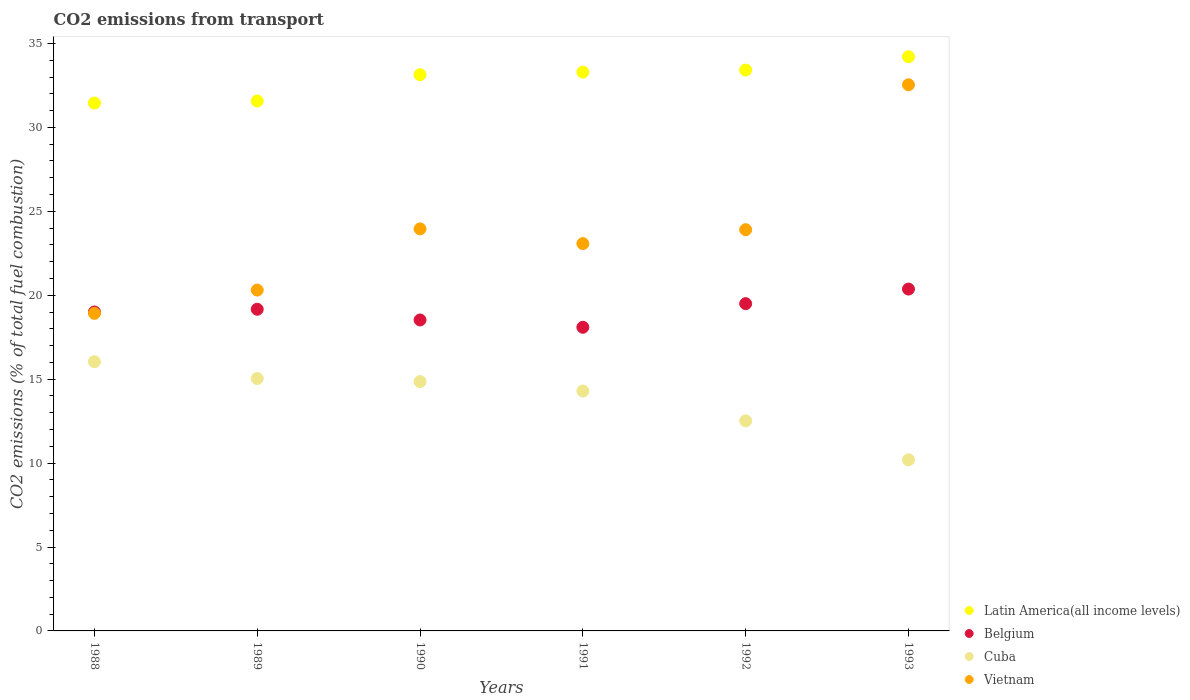How many different coloured dotlines are there?
Make the answer very short. 4. Is the number of dotlines equal to the number of legend labels?
Offer a terse response. Yes. What is the total CO2 emitted in Vietnam in 1990?
Your response must be concise. 23.95. Across all years, what is the maximum total CO2 emitted in Cuba?
Your response must be concise. 16.04. Across all years, what is the minimum total CO2 emitted in Cuba?
Your answer should be compact. 10.19. What is the total total CO2 emitted in Belgium in the graph?
Ensure brevity in your answer.  114.66. What is the difference between the total CO2 emitted in Belgium in 1989 and that in 1993?
Make the answer very short. -1.2. What is the difference between the total CO2 emitted in Vietnam in 1992 and the total CO2 emitted in Cuba in 1989?
Offer a terse response. 8.87. What is the average total CO2 emitted in Cuba per year?
Your answer should be very brief. 13.82. In the year 1993, what is the difference between the total CO2 emitted in Belgium and total CO2 emitted in Vietnam?
Your answer should be compact. -12.17. In how many years, is the total CO2 emitted in Cuba greater than 28?
Offer a terse response. 0. What is the ratio of the total CO2 emitted in Cuba in 1989 to that in 1993?
Your response must be concise. 1.48. What is the difference between the highest and the second highest total CO2 emitted in Latin America(all income levels)?
Your answer should be very brief. 0.79. What is the difference between the highest and the lowest total CO2 emitted in Cuba?
Provide a short and direct response. 5.85. In how many years, is the total CO2 emitted in Vietnam greater than the average total CO2 emitted in Vietnam taken over all years?
Offer a very short reply. 3. Is it the case that in every year, the sum of the total CO2 emitted in Vietnam and total CO2 emitted in Cuba  is greater than the sum of total CO2 emitted in Belgium and total CO2 emitted in Latin America(all income levels)?
Offer a very short reply. No. Is the total CO2 emitted in Vietnam strictly greater than the total CO2 emitted in Cuba over the years?
Offer a very short reply. Yes. Is the total CO2 emitted in Vietnam strictly less than the total CO2 emitted in Belgium over the years?
Ensure brevity in your answer.  No. How many dotlines are there?
Your response must be concise. 4. How many years are there in the graph?
Your response must be concise. 6. Are the values on the major ticks of Y-axis written in scientific E-notation?
Offer a terse response. No. Does the graph contain any zero values?
Offer a very short reply. No. Where does the legend appear in the graph?
Keep it short and to the point. Bottom right. What is the title of the graph?
Your answer should be very brief. CO2 emissions from transport. Does "Russian Federation" appear as one of the legend labels in the graph?
Offer a very short reply. No. What is the label or title of the X-axis?
Offer a very short reply. Years. What is the label or title of the Y-axis?
Make the answer very short. CO2 emissions (% of total fuel combustion). What is the CO2 emissions (% of total fuel combustion) in Latin America(all income levels) in 1988?
Your answer should be very brief. 31.45. What is the CO2 emissions (% of total fuel combustion) in Belgium in 1988?
Provide a short and direct response. 19. What is the CO2 emissions (% of total fuel combustion) of Cuba in 1988?
Offer a terse response. 16.04. What is the CO2 emissions (% of total fuel combustion) in Vietnam in 1988?
Ensure brevity in your answer.  18.92. What is the CO2 emissions (% of total fuel combustion) of Latin America(all income levels) in 1989?
Your answer should be compact. 31.57. What is the CO2 emissions (% of total fuel combustion) of Belgium in 1989?
Ensure brevity in your answer.  19.17. What is the CO2 emissions (% of total fuel combustion) of Cuba in 1989?
Your answer should be compact. 15.04. What is the CO2 emissions (% of total fuel combustion) in Vietnam in 1989?
Offer a terse response. 20.31. What is the CO2 emissions (% of total fuel combustion) in Latin America(all income levels) in 1990?
Make the answer very short. 33.14. What is the CO2 emissions (% of total fuel combustion) of Belgium in 1990?
Ensure brevity in your answer.  18.53. What is the CO2 emissions (% of total fuel combustion) in Cuba in 1990?
Offer a very short reply. 14.86. What is the CO2 emissions (% of total fuel combustion) in Vietnam in 1990?
Offer a terse response. 23.95. What is the CO2 emissions (% of total fuel combustion) in Latin America(all income levels) in 1991?
Make the answer very short. 33.29. What is the CO2 emissions (% of total fuel combustion) of Belgium in 1991?
Offer a terse response. 18.09. What is the CO2 emissions (% of total fuel combustion) of Cuba in 1991?
Offer a very short reply. 14.3. What is the CO2 emissions (% of total fuel combustion) of Vietnam in 1991?
Give a very brief answer. 23.08. What is the CO2 emissions (% of total fuel combustion) in Latin America(all income levels) in 1992?
Offer a terse response. 33.42. What is the CO2 emissions (% of total fuel combustion) in Belgium in 1992?
Offer a very short reply. 19.5. What is the CO2 emissions (% of total fuel combustion) of Cuba in 1992?
Provide a succinct answer. 12.52. What is the CO2 emissions (% of total fuel combustion) in Vietnam in 1992?
Your response must be concise. 23.91. What is the CO2 emissions (% of total fuel combustion) of Latin America(all income levels) in 1993?
Offer a very short reply. 34.21. What is the CO2 emissions (% of total fuel combustion) of Belgium in 1993?
Give a very brief answer. 20.37. What is the CO2 emissions (% of total fuel combustion) in Cuba in 1993?
Ensure brevity in your answer.  10.19. What is the CO2 emissions (% of total fuel combustion) of Vietnam in 1993?
Ensure brevity in your answer.  32.54. Across all years, what is the maximum CO2 emissions (% of total fuel combustion) of Latin America(all income levels)?
Give a very brief answer. 34.21. Across all years, what is the maximum CO2 emissions (% of total fuel combustion) in Belgium?
Your response must be concise. 20.37. Across all years, what is the maximum CO2 emissions (% of total fuel combustion) in Cuba?
Give a very brief answer. 16.04. Across all years, what is the maximum CO2 emissions (% of total fuel combustion) in Vietnam?
Give a very brief answer. 32.54. Across all years, what is the minimum CO2 emissions (% of total fuel combustion) in Latin America(all income levels)?
Keep it short and to the point. 31.45. Across all years, what is the minimum CO2 emissions (% of total fuel combustion) of Belgium?
Ensure brevity in your answer.  18.09. Across all years, what is the minimum CO2 emissions (% of total fuel combustion) of Cuba?
Provide a succinct answer. 10.19. Across all years, what is the minimum CO2 emissions (% of total fuel combustion) of Vietnam?
Your answer should be compact. 18.92. What is the total CO2 emissions (% of total fuel combustion) of Latin America(all income levels) in the graph?
Keep it short and to the point. 197.09. What is the total CO2 emissions (% of total fuel combustion) of Belgium in the graph?
Provide a succinct answer. 114.66. What is the total CO2 emissions (% of total fuel combustion) of Cuba in the graph?
Provide a short and direct response. 82.94. What is the total CO2 emissions (% of total fuel combustion) in Vietnam in the graph?
Ensure brevity in your answer.  142.71. What is the difference between the CO2 emissions (% of total fuel combustion) in Latin America(all income levels) in 1988 and that in 1989?
Your answer should be very brief. -0.12. What is the difference between the CO2 emissions (% of total fuel combustion) in Belgium in 1988 and that in 1989?
Keep it short and to the point. -0.16. What is the difference between the CO2 emissions (% of total fuel combustion) in Vietnam in 1988 and that in 1989?
Offer a very short reply. -1.39. What is the difference between the CO2 emissions (% of total fuel combustion) in Latin America(all income levels) in 1988 and that in 1990?
Your response must be concise. -1.69. What is the difference between the CO2 emissions (% of total fuel combustion) of Belgium in 1988 and that in 1990?
Ensure brevity in your answer.  0.48. What is the difference between the CO2 emissions (% of total fuel combustion) of Cuba in 1988 and that in 1990?
Give a very brief answer. 1.18. What is the difference between the CO2 emissions (% of total fuel combustion) of Vietnam in 1988 and that in 1990?
Provide a succinct answer. -5.03. What is the difference between the CO2 emissions (% of total fuel combustion) in Latin America(all income levels) in 1988 and that in 1991?
Provide a succinct answer. -1.84. What is the difference between the CO2 emissions (% of total fuel combustion) in Belgium in 1988 and that in 1991?
Make the answer very short. 0.91. What is the difference between the CO2 emissions (% of total fuel combustion) of Cuba in 1988 and that in 1991?
Your answer should be compact. 1.74. What is the difference between the CO2 emissions (% of total fuel combustion) of Vietnam in 1988 and that in 1991?
Your answer should be very brief. -4.16. What is the difference between the CO2 emissions (% of total fuel combustion) in Latin America(all income levels) in 1988 and that in 1992?
Offer a terse response. -1.97. What is the difference between the CO2 emissions (% of total fuel combustion) of Belgium in 1988 and that in 1992?
Give a very brief answer. -0.5. What is the difference between the CO2 emissions (% of total fuel combustion) in Cuba in 1988 and that in 1992?
Give a very brief answer. 3.52. What is the difference between the CO2 emissions (% of total fuel combustion) of Vietnam in 1988 and that in 1992?
Your answer should be very brief. -4.98. What is the difference between the CO2 emissions (% of total fuel combustion) in Latin America(all income levels) in 1988 and that in 1993?
Your response must be concise. -2.76. What is the difference between the CO2 emissions (% of total fuel combustion) of Belgium in 1988 and that in 1993?
Ensure brevity in your answer.  -1.36. What is the difference between the CO2 emissions (% of total fuel combustion) of Cuba in 1988 and that in 1993?
Your response must be concise. 5.85. What is the difference between the CO2 emissions (% of total fuel combustion) in Vietnam in 1988 and that in 1993?
Ensure brevity in your answer.  -13.62. What is the difference between the CO2 emissions (% of total fuel combustion) in Latin America(all income levels) in 1989 and that in 1990?
Keep it short and to the point. -1.57. What is the difference between the CO2 emissions (% of total fuel combustion) of Belgium in 1989 and that in 1990?
Make the answer very short. 0.64. What is the difference between the CO2 emissions (% of total fuel combustion) of Cuba in 1989 and that in 1990?
Keep it short and to the point. 0.18. What is the difference between the CO2 emissions (% of total fuel combustion) of Vietnam in 1989 and that in 1990?
Your answer should be very brief. -3.65. What is the difference between the CO2 emissions (% of total fuel combustion) of Latin America(all income levels) in 1989 and that in 1991?
Offer a terse response. -1.72. What is the difference between the CO2 emissions (% of total fuel combustion) in Belgium in 1989 and that in 1991?
Ensure brevity in your answer.  1.07. What is the difference between the CO2 emissions (% of total fuel combustion) of Cuba in 1989 and that in 1991?
Keep it short and to the point. 0.74. What is the difference between the CO2 emissions (% of total fuel combustion) in Vietnam in 1989 and that in 1991?
Your answer should be compact. -2.77. What is the difference between the CO2 emissions (% of total fuel combustion) of Latin America(all income levels) in 1989 and that in 1992?
Offer a terse response. -1.85. What is the difference between the CO2 emissions (% of total fuel combustion) of Belgium in 1989 and that in 1992?
Give a very brief answer. -0.33. What is the difference between the CO2 emissions (% of total fuel combustion) of Cuba in 1989 and that in 1992?
Provide a succinct answer. 2.52. What is the difference between the CO2 emissions (% of total fuel combustion) of Vietnam in 1989 and that in 1992?
Keep it short and to the point. -3.6. What is the difference between the CO2 emissions (% of total fuel combustion) in Latin America(all income levels) in 1989 and that in 1993?
Your response must be concise. -2.64. What is the difference between the CO2 emissions (% of total fuel combustion) in Belgium in 1989 and that in 1993?
Your answer should be very brief. -1.2. What is the difference between the CO2 emissions (% of total fuel combustion) of Cuba in 1989 and that in 1993?
Give a very brief answer. 4.85. What is the difference between the CO2 emissions (% of total fuel combustion) of Vietnam in 1989 and that in 1993?
Provide a short and direct response. -12.23. What is the difference between the CO2 emissions (% of total fuel combustion) of Latin America(all income levels) in 1990 and that in 1991?
Offer a very short reply. -0.15. What is the difference between the CO2 emissions (% of total fuel combustion) of Belgium in 1990 and that in 1991?
Offer a very short reply. 0.44. What is the difference between the CO2 emissions (% of total fuel combustion) of Cuba in 1990 and that in 1991?
Ensure brevity in your answer.  0.56. What is the difference between the CO2 emissions (% of total fuel combustion) in Vietnam in 1990 and that in 1991?
Provide a succinct answer. 0.88. What is the difference between the CO2 emissions (% of total fuel combustion) in Latin America(all income levels) in 1990 and that in 1992?
Your answer should be very brief. -0.27. What is the difference between the CO2 emissions (% of total fuel combustion) in Belgium in 1990 and that in 1992?
Make the answer very short. -0.97. What is the difference between the CO2 emissions (% of total fuel combustion) in Cuba in 1990 and that in 1992?
Give a very brief answer. 2.34. What is the difference between the CO2 emissions (% of total fuel combustion) in Vietnam in 1990 and that in 1992?
Ensure brevity in your answer.  0.05. What is the difference between the CO2 emissions (% of total fuel combustion) of Latin America(all income levels) in 1990 and that in 1993?
Make the answer very short. -1.07. What is the difference between the CO2 emissions (% of total fuel combustion) in Belgium in 1990 and that in 1993?
Give a very brief answer. -1.84. What is the difference between the CO2 emissions (% of total fuel combustion) of Cuba in 1990 and that in 1993?
Your answer should be very brief. 4.66. What is the difference between the CO2 emissions (% of total fuel combustion) of Vietnam in 1990 and that in 1993?
Ensure brevity in your answer.  -8.59. What is the difference between the CO2 emissions (% of total fuel combustion) of Latin America(all income levels) in 1991 and that in 1992?
Give a very brief answer. -0.13. What is the difference between the CO2 emissions (% of total fuel combustion) in Belgium in 1991 and that in 1992?
Provide a succinct answer. -1.41. What is the difference between the CO2 emissions (% of total fuel combustion) of Cuba in 1991 and that in 1992?
Offer a very short reply. 1.78. What is the difference between the CO2 emissions (% of total fuel combustion) of Vietnam in 1991 and that in 1992?
Keep it short and to the point. -0.83. What is the difference between the CO2 emissions (% of total fuel combustion) of Latin America(all income levels) in 1991 and that in 1993?
Your answer should be very brief. -0.92. What is the difference between the CO2 emissions (% of total fuel combustion) of Belgium in 1991 and that in 1993?
Ensure brevity in your answer.  -2.28. What is the difference between the CO2 emissions (% of total fuel combustion) of Cuba in 1991 and that in 1993?
Make the answer very short. 4.1. What is the difference between the CO2 emissions (% of total fuel combustion) of Vietnam in 1991 and that in 1993?
Ensure brevity in your answer.  -9.46. What is the difference between the CO2 emissions (% of total fuel combustion) in Latin America(all income levels) in 1992 and that in 1993?
Offer a terse response. -0.79. What is the difference between the CO2 emissions (% of total fuel combustion) in Belgium in 1992 and that in 1993?
Ensure brevity in your answer.  -0.87. What is the difference between the CO2 emissions (% of total fuel combustion) of Cuba in 1992 and that in 1993?
Ensure brevity in your answer.  2.32. What is the difference between the CO2 emissions (% of total fuel combustion) in Vietnam in 1992 and that in 1993?
Provide a short and direct response. -8.63. What is the difference between the CO2 emissions (% of total fuel combustion) in Latin America(all income levels) in 1988 and the CO2 emissions (% of total fuel combustion) in Belgium in 1989?
Offer a very short reply. 12.29. What is the difference between the CO2 emissions (% of total fuel combustion) of Latin America(all income levels) in 1988 and the CO2 emissions (% of total fuel combustion) of Cuba in 1989?
Give a very brief answer. 16.41. What is the difference between the CO2 emissions (% of total fuel combustion) of Latin America(all income levels) in 1988 and the CO2 emissions (% of total fuel combustion) of Vietnam in 1989?
Give a very brief answer. 11.14. What is the difference between the CO2 emissions (% of total fuel combustion) in Belgium in 1988 and the CO2 emissions (% of total fuel combustion) in Cuba in 1989?
Give a very brief answer. 3.97. What is the difference between the CO2 emissions (% of total fuel combustion) in Belgium in 1988 and the CO2 emissions (% of total fuel combustion) in Vietnam in 1989?
Make the answer very short. -1.3. What is the difference between the CO2 emissions (% of total fuel combustion) of Cuba in 1988 and the CO2 emissions (% of total fuel combustion) of Vietnam in 1989?
Your answer should be very brief. -4.27. What is the difference between the CO2 emissions (% of total fuel combustion) in Latin America(all income levels) in 1988 and the CO2 emissions (% of total fuel combustion) in Belgium in 1990?
Your response must be concise. 12.92. What is the difference between the CO2 emissions (% of total fuel combustion) of Latin America(all income levels) in 1988 and the CO2 emissions (% of total fuel combustion) of Cuba in 1990?
Offer a very short reply. 16.6. What is the difference between the CO2 emissions (% of total fuel combustion) of Latin America(all income levels) in 1988 and the CO2 emissions (% of total fuel combustion) of Vietnam in 1990?
Your answer should be very brief. 7.5. What is the difference between the CO2 emissions (% of total fuel combustion) in Belgium in 1988 and the CO2 emissions (% of total fuel combustion) in Cuba in 1990?
Ensure brevity in your answer.  4.15. What is the difference between the CO2 emissions (% of total fuel combustion) of Belgium in 1988 and the CO2 emissions (% of total fuel combustion) of Vietnam in 1990?
Ensure brevity in your answer.  -4.95. What is the difference between the CO2 emissions (% of total fuel combustion) in Cuba in 1988 and the CO2 emissions (% of total fuel combustion) in Vietnam in 1990?
Your answer should be very brief. -7.91. What is the difference between the CO2 emissions (% of total fuel combustion) of Latin America(all income levels) in 1988 and the CO2 emissions (% of total fuel combustion) of Belgium in 1991?
Offer a terse response. 13.36. What is the difference between the CO2 emissions (% of total fuel combustion) of Latin America(all income levels) in 1988 and the CO2 emissions (% of total fuel combustion) of Cuba in 1991?
Ensure brevity in your answer.  17.16. What is the difference between the CO2 emissions (% of total fuel combustion) in Latin America(all income levels) in 1988 and the CO2 emissions (% of total fuel combustion) in Vietnam in 1991?
Your answer should be compact. 8.37. What is the difference between the CO2 emissions (% of total fuel combustion) of Belgium in 1988 and the CO2 emissions (% of total fuel combustion) of Cuba in 1991?
Keep it short and to the point. 4.71. What is the difference between the CO2 emissions (% of total fuel combustion) in Belgium in 1988 and the CO2 emissions (% of total fuel combustion) in Vietnam in 1991?
Keep it short and to the point. -4.07. What is the difference between the CO2 emissions (% of total fuel combustion) in Cuba in 1988 and the CO2 emissions (% of total fuel combustion) in Vietnam in 1991?
Provide a short and direct response. -7.04. What is the difference between the CO2 emissions (% of total fuel combustion) of Latin America(all income levels) in 1988 and the CO2 emissions (% of total fuel combustion) of Belgium in 1992?
Your answer should be compact. 11.95. What is the difference between the CO2 emissions (% of total fuel combustion) of Latin America(all income levels) in 1988 and the CO2 emissions (% of total fuel combustion) of Cuba in 1992?
Your response must be concise. 18.93. What is the difference between the CO2 emissions (% of total fuel combustion) of Latin America(all income levels) in 1988 and the CO2 emissions (% of total fuel combustion) of Vietnam in 1992?
Your answer should be compact. 7.55. What is the difference between the CO2 emissions (% of total fuel combustion) of Belgium in 1988 and the CO2 emissions (% of total fuel combustion) of Cuba in 1992?
Offer a very short reply. 6.49. What is the difference between the CO2 emissions (% of total fuel combustion) of Belgium in 1988 and the CO2 emissions (% of total fuel combustion) of Vietnam in 1992?
Your answer should be compact. -4.9. What is the difference between the CO2 emissions (% of total fuel combustion) of Cuba in 1988 and the CO2 emissions (% of total fuel combustion) of Vietnam in 1992?
Your response must be concise. -7.87. What is the difference between the CO2 emissions (% of total fuel combustion) in Latin America(all income levels) in 1988 and the CO2 emissions (% of total fuel combustion) in Belgium in 1993?
Offer a terse response. 11.08. What is the difference between the CO2 emissions (% of total fuel combustion) of Latin America(all income levels) in 1988 and the CO2 emissions (% of total fuel combustion) of Cuba in 1993?
Offer a terse response. 21.26. What is the difference between the CO2 emissions (% of total fuel combustion) in Latin America(all income levels) in 1988 and the CO2 emissions (% of total fuel combustion) in Vietnam in 1993?
Your answer should be compact. -1.09. What is the difference between the CO2 emissions (% of total fuel combustion) of Belgium in 1988 and the CO2 emissions (% of total fuel combustion) of Cuba in 1993?
Make the answer very short. 8.81. What is the difference between the CO2 emissions (% of total fuel combustion) of Belgium in 1988 and the CO2 emissions (% of total fuel combustion) of Vietnam in 1993?
Provide a short and direct response. -13.54. What is the difference between the CO2 emissions (% of total fuel combustion) of Cuba in 1988 and the CO2 emissions (% of total fuel combustion) of Vietnam in 1993?
Provide a succinct answer. -16.5. What is the difference between the CO2 emissions (% of total fuel combustion) in Latin America(all income levels) in 1989 and the CO2 emissions (% of total fuel combustion) in Belgium in 1990?
Provide a short and direct response. 13.05. What is the difference between the CO2 emissions (% of total fuel combustion) in Latin America(all income levels) in 1989 and the CO2 emissions (% of total fuel combustion) in Cuba in 1990?
Make the answer very short. 16.72. What is the difference between the CO2 emissions (% of total fuel combustion) of Latin America(all income levels) in 1989 and the CO2 emissions (% of total fuel combustion) of Vietnam in 1990?
Offer a terse response. 7.62. What is the difference between the CO2 emissions (% of total fuel combustion) in Belgium in 1989 and the CO2 emissions (% of total fuel combustion) in Cuba in 1990?
Provide a short and direct response. 4.31. What is the difference between the CO2 emissions (% of total fuel combustion) in Belgium in 1989 and the CO2 emissions (% of total fuel combustion) in Vietnam in 1990?
Make the answer very short. -4.79. What is the difference between the CO2 emissions (% of total fuel combustion) of Cuba in 1989 and the CO2 emissions (% of total fuel combustion) of Vietnam in 1990?
Your response must be concise. -8.91. What is the difference between the CO2 emissions (% of total fuel combustion) in Latin America(all income levels) in 1989 and the CO2 emissions (% of total fuel combustion) in Belgium in 1991?
Give a very brief answer. 13.48. What is the difference between the CO2 emissions (% of total fuel combustion) in Latin America(all income levels) in 1989 and the CO2 emissions (% of total fuel combustion) in Cuba in 1991?
Your answer should be very brief. 17.28. What is the difference between the CO2 emissions (% of total fuel combustion) in Latin America(all income levels) in 1989 and the CO2 emissions (% of total fuel combustion) in Vietnam in 1991?
Your answer should be very brief. 8.5. What is the difference between the CO2 emissions (% of total fuel combustion) in Belgium in 1989 and the CO2 emissions (% of total fuel combustion) in Cuba in 1991?
Your response must be concise. 4.87. What is the difference between the CO2 emissions (% of total fuel combustion) of Belgium in 1989 and the CO2 emissions (% of total fuel combustion) of Vietnam in 1991?
Make the answer very short. -3.91. What is the difference between the CO2 emissions (% of total fuel combustion) of Cuba in 1989 and the CO2 emissions (% of total fuel combustion) of Vietnam in 1991?
Your response must be concise. -8.04. What is the difference between the CO2 emissions (% of total fuel combustion) in Latin America(all income levels) in 1989 and the CO2 emissions (% of total fuel combustion) in Belgium in 1992?
Make the answer very short. 12.07. What is the difference between the CO2 emissions (% of total fuel combustion) of Latin America(all income levels) in 1989 and the CO2 emissions (% of total fuel combustion) of Cuba in 1992?
Provide a succinct answer. 19.06. What is the difference between the CO2 emissions (% of total fuel combustion) of Latin America(all income levels) in 1989 and the CO2 emissions (% of total fuel combustion) of Vietnam in 1992?
Keep it short and to the point. 7.67. What is the difference between the CO2 emissions (% of total fuel combustion) of Belgium in 1989 and the CO2 emissions (% of total fuel combustion) of Cuba in 1992?
Your answer should be very brief. 6.65. What is the difference between the CO2 emissions (% of total fuel combustion) of Belgium in 1989 and the CO2 emissions (% of total fuel combustion) of Vietnam in 1992?
Your answer should be compact. -4.74. What is the difference between the CO2 emissions (% of total fuel combustion) in Cuba in 1989 and the CO2 emissions (% of total fuel combustion) in Vietnam in 1992?
Ensure brevity in your answer.  -8.87. What is the difference between the CO2 emissions (% of total fuel combustion) in Latin America(all income levels) in 1989 and the CO2 emissions (% of total fuel combustion) in Belgium in 1993?
Give a very brief answer. 11.2. What is the difference between the CO2 emissions (% of total fuel combustion) in Latin America(all income levels) in 1989 and the CO2 emissions (% of total fuel combustion) in Cuba in 1993?
Keep it short and to the point. 21.38. What is the difference between the CO2 emissions (% of total fuel combustion) of Latin America(all income levels) in 1989 and the CO2 emissions (% of total fuel combustion) of Vietnam in 1993?
Your answer should be compact. -0.97. What is the difference between the CO2 emissions (% of total fuel combustion) in Belgium in 1989 and the CO2 emissions (% of total fuel combustion) in Cuba in 1993?
Make the answer very short. 8.97. What is the difference between the CO2 emissions (% of total fuel combustion) of Belgium in 1989 and the CO2 emissions (% of total fuel combustion) of Vietnam in 1993?
Ensure brevity in your answer.  -13.37. What is the difference between the CO2 emissions (% of total fuel combustion) in Cuba in 1989 and the CO2 emissions (% of total fuel combustion) in Vietnam in 1993?
Offer a very short reply. -17.5. What is the difference between the CO2 emissions (% of total fuel combustion) of Latin America(all income levels) in 1990 and the CO2 emissions (% of total fuel combustion) of Belgium in 1991?
Offer a very short reply. 15.05. What is the difference between the CO2 emissions (% of total fuel combustion) in Latin America(all income levels) in 1990 and the CO2 emissions (% of total fuel combustion) in Cuba in 1991?
Your answer should be very brief. 18.85. What is the difference between the CO2 emissions (% of total fuel combustion) in Latin America(all income levels) in 1990 and the CO2 emissions (% of total fuel combustion) in Vietnam in 1991?
Keep it short and to the point. 10.07. What is the difference between the CO2 emissions (% of total fuel combustion) in Belgium in 1990 and the CO2 emissions (% of total fuel combustion) in Cuba in 1991?
Offer a terse response. 4.23. What is the difference between the CO2 emissions (% of total fuel combustion) of Belgium in 1990 and the CO2 emissions (% of total fuel combustion) of Vietnam in 1991?
Provide a succinct answer. -4.55. What is the difference between the CO2 emissions (% of total fuel combustion) in Cuba in 1990 and the CO2 emissions (% of total fuel combustion) in Vietnam in 1991?
Provide a short and direct response. -8.22. What is the difference between the CO2 emissions (% of total fuel combustion) of Latin America(all income levels) in 1990 and the CO2 emissions (% of total fuel combustion) of Belgium in 1992?
Give a very brief answer. 13.64. What is the difference between the CO2 emissions (% of total fuel combustion) of Latin America(all income levels) in 1990 and the CO2 emissions (% of total fuel combustion) of Cuba in 1992?
Make the answer very short. 20.63. What is the difference between the CO2 emissions (% of total fuel combustion) of Latin America(all income levels) in 1990 and the CO2 emissions (% of total fuel combustion) of Vietnam in 1992?
Make the answer very short. 9.24. What is the difference between the CO2 emissions (% of total fuel combustion) of Belgium in 1990 and the CO2 emissions (% of total fuel combustion) of Cuba in 1992?
Keep it short and to the point. 6.01. What is the difference between the CO2 emissions (% of total fuel combustion) in Belgium in 1990 and the CO2 emissions (% of total fuel combustion) in Vietnam in 1992?
Keep it short and to the point. -5.38. What is the difference between the CO2 emissions (% of total fuel combustion) in Cuba in 1990 and the CO2 emissions (% of total fuel combustion) in Vietnam in 1992?
Ensure brevity in your answer.  -9.05. What is the difference between the CO2 emissions (% of total fuel combustion) of Latin America(all income levels) in 1990 and the CO2 emissions (% of total fuel combustion) of Belgium in 1993?
Provide a succinct answer. 12.78. What is the difference between the CO2 emissions (% of total fuel combustion) in Latin America(all income levels) in 1990 and the CO2 emissions (% of total fuel combustion) in Cuba in 1993?
Your response must be concise. 22.95. What is the difference between the CO2 emissions (% of total fuel combustion) of Latin America(all income levels) in 1990 and the CO2 emissions (% of total fuel combustion) of Vietnam in 1993?
Provide a succinct answer. 0.6. What is the difference between the CO2 emissions (% of total fuel combustion) of Belgium in 1990 and the CO2 emissions (% of total fuel combustion) of Cuba in 1993?
Make the answer very short. 8.33. What is the difference between the CO2 emissions (% of total fuel combustion) of Belgium in 1990 and the CO2 emissions (% of total fuel combustion) of Vietnam in 1993?
Your response must be concise. -14.01. What is the difference between the CO2 emissions (% of total fuel combustion) in Cuba in 1990 and the CO2 emissions (% of total fuel combustion) in Vietnam in 1993?
Provide a succinct answer. -17.68. What is the difference between the CO2 emissions (% of total fuel combustion) in Latin America(all income levels) in 1991 and the CO2 emissions (% of total fuel combustion) in Belgium in 1992?
Offer a terse response. 13.79. What is the difference between the CO2 emissions (% of total fuel combustion) in Latin America(all income levels) in 1991 and the CO2 emissions (% of total fuel combustion) in Cuba in 1992?
Offer a very short reply. 20.78. What is the difference between the CO2 emissions (% of total fuel combustion) of Latin America(all income levels) in 1991 and the CO2 emissions (% of total fuel combustion) of Vietnam in 1992?
Offer a very short reply. 9.39. What is the difference between the CO2 emissions (% of total fuel combustion) of Belgium in 1991 and the CO2 emissions (% of total fuel combustion) of Cuba in 1992?
Provide a succinct answer. 5.57. What is the difference between the CO2 emissions (% of total fuel combustion) of Belgium in 1991 and the CO2 emissions (% of total fuel combustion) of Vietnam in 1992?
Your response must be concise. -5.81. What is the difference between the CO2 emissions (% of total fuel combustion) of Cuba in 1991 and the CO2 emissions (% of total fuel combustion) of Vietnam in 1992?
Give a very brief answer. -9.61. What is the difference between the CO2 emissions (% of total fuel combustion) of Latin America(all income levels) in 1991 and the CO2 emissions (% of total fuel combustion) of Belgium in 1993?
Ensure brevity in your answer.  12.93. What is the difference between the CO2 emissions (% of total fuel combustion) of Latin America(all income levels) in 1991 and the CO2 emissions (% of total fuel combustion) of Cuba in 1993?
Provide a short and direct response. 23.1. What is the difference between the CO2 emissions (% of total fuel combustion) in Latin America(all income levels) in 1991 and the CO2 emissions (% of total fuel combustion) in Vietnam in 1993?
Keep it short and to the point. 0.75. What is the difference between the CO2 emissions (% of total fuel combustion) of Belgium in 1991 and the CO2 emissions (% of total fuel combustion) of Cuba in 1993?
Offer a terse response. 7.9. What is the difference between the CO2 emissions (% of total fuel combustion) of Belgium in 1991 and the CO2 emissions (% of total fuel combustion) of Vietnam in 1993?
Offer a terse response. -14.45. What is the difference between the CO2 emissions (% of total fuel combustion) in Cuba in 1991 and the CO2 emissions (% of total fuel combustion) in Vietnam in 1993?
Offer a very short reply. -18.24. What is the difference between the CO2 emissions (% of total fuel combustion) of Latin America(all income levels) in 1992 and the CO2 emissions (% of total fuel combustion) of Belgium in 1993?
Give a very brief answer. 13.05. What is the difference between the CO2 emissions (% of total fuel combustion) of Latin America(all income levels) in 1992 and the CO2 emissions (% of total fuel combustion) of Cuba in 1993?
Keep it short and to the point. 23.23. What is the difference between the CO2 emissions (% of total fuel combustion) in Latin America(all income levels) in 1992 and the CO2 emissions (% of total fuel combustion) in Vietnam in 1993?
Give a very brief answer. 0.88. What is the difference between the CO2 emissions (% of total fuel combustion) in Belgium in 1992 and the CO2 emissions (% of total fuel combustion) in Cuba in 1993?
Ensure brevity in your answer.  9.31. What is the difference between the CO2 emissions (% of total fuel combustion) of Belgium in 1992 and the CO2 emissions (% of total fuel combustion) of Vietnam in 1993?
Provide a succinct answer. -13.04. What is the difference between the CO2 emissions (% of total fuel combustion) in Cuba in 1992 and the CO2 emissions (% of total fuel combustion) in Vietnam in 1993?
Your answer should be very brief. -20.02. What is the average CO2 emissions (% of total fuel combustion) of Latin America(all income levels) per year?
Your answer should be compact. 32.85. What is the average CO2 emissions (% of total fuel combustion) in Belgium per year?
Ensure brevity in your answer.  19.11. What is the average CO2 emissions (% of total fuel combustion) of Cuba per year?
Offer a terse response. 13.82. What is the average CO2 emissions (% of total fuel combustion) of Vietnam per year?
Your answer should be compact. 23.78. In the year 1988, what is the difference between the CO2 emissions (% of total fuel combustion) of Latin America(all income levels) and CO2 emissions (% of total fuel combustion) of Belgium?
Ensure brevity in your answer.  12.45. In the year 1988, what is the difference between the CO2 emissions (% of total fuel combustion) in Latin America(all income levels) and CO2 emissions (% of total fuel combustion) in Cuba?
Provide a succinct answer. 15.41. In the year 1988, what is the difference between the CO2 emissions (% of total fuel combustion) in Latin America(all income levels) and CO2 emissions (% of total fuel combustion) in Vietnam?
Offer a very short reply. 12.53. In the year 1988, what is the difference between the CO2 emissions (% of total fuel combustion) of Belgium and CO2 emissions (% of total fuel combustion) of Cuba?
Your answer should be compact. 2.96. In the year 1988, what is the difference between the CO2 emissions (% of total fuel combustion) in Belgium and CO2 emissions (% of total fuel combustion) in Vietnam?
Make the answer very short. 0.08. In the year 1988, what is the difference between the CO2 emissions (% of total fuel combustion) in Cuba and CO2 emissions (% of total fuel combustion) in Vietnam?
Your answer should be very brief. -2.88. In the year 1989, what is the difference between the CO2 emissions (% of total fuel combustion) in Latin America(all income levels) and CO2 emissions (% of total fuel combustion) in Belgium?
Offer a terse response. 12.41. In the year 1989, what is the difference between the CO2 emissions (% of total fuel combustion) in Latin America(all income levels) and CO2 emissions (% of total fuel combustion) in Cuba?
Offer a terse response. 16.53. In the year 1989, what is the difference between the CO2 emissions (% of total fuel combustion) in Latin America(all income levels) and CO2 emissions (% of total fuel combustion) in Vietnam?
Keep it short and to the point. 11.26. In the year 1989, what is the difference between the CO2 emissions (% of total fuel combustion) in Belgium and CO2 emissions (% of total fuel combustion) in Cuba?
Keep it short and to the point. 4.13. In the year 1989, what is the difference between the CO2 emissions (% of total fuel combustion) in Belgium and CO2 emissions (% of total fuel combustion) in Vietnam?
Keep it short and to the point. -1.14. In the year 1989, what is the difference between the CO2 emissions (% of total fuel combustion) in Cuba and CO2 emissions (% of total fuel combustion) in Vietnam?
Offer a very short reply. -5.27. In the year 1990, what is the difference between the CO2 emissions (% of total fuel combustion) in Latin America(all income levels) and CO2 emissions (% of total fuel combustion) in Belgium?
Offer a terse response. 14.62. In the year 1990, what is the difference between the CO2 emissions (% of total fuel combustion) in Latin America(all income levels) and CO2 emissions (% of total fuel combustion) in Cuba?
Ensure brevity in your answer.  18.29. In the year 1990, what is the difference between the CO2 emissions (% of total fuel combustion) in Latin America(all income levels) and CO2 emissions (% of total fuel combustion) in Vietnam?
Offer a terse response. 9.19. In the year 1990, what is the difference between the CO2 emissions (% of total fuel combustion) in Belgium and CO2 emissions (% of total fuel combustion) in Cuba?
Ensure brevity in your answer.  3.67. In the year 1990, what is the difference between the CO2 emissions (% of total fuel combustion) in Belgium and CO2 emissions (% of total fuel combustion) in Vietnam?
Make the answer very short. -5.43. In the year 1990, what is the difference between the CO2 emissions (% of total fuel combustion) of Cuba and CO2 emissions (% of total fuel combustion) of Vietnam?
Your answer should be very brief. -9.1. In the year 1991, what is the difference between the CO2 emissions (% of total fuel combustion) of Latin America(all income levels) and CO2 emissions (% of total fuel combustion) of Belgium?
Provide a short and direct response. 15.2. In the year 1991, what is the difference between the CO2 emissions (% of total fuel combustion) in Latin America(all income levels) and CO2 emissions (% of total fuel combustion) in Cuba?
Provide a short and direct response. 19. In the year 1991, what is the difference between the CO2 emissions (% of total fuel combustion) of Latin America(all income levels) and CO2 emissions (% of total fuel combustion) of Vietnam?
Ensure brevity in your answer.  10.22. In the year 1991, what is the difference between the CO2 emissions (% of total fuel combustion) in Belgium and CO2 emissions (% of total fuel combustion) in Cuba?
Give a very brief answer. 3.8. In the year 1991, what is the difference between the CO2 emissions (% of total fuel combustion) in Belgium and CO2 emissions (% of total fuel combustion) in Vietnam?
Ensure brevity in your answer.  -4.99. In the year 1991, what is the difference between the CO2 emissions (% of total fuel combustion) of Cuba and CO2 emissions (% of total fuel combustion) of Vietnam?
Keep it short and to the point. -8.78. In the year 1992, what is the difference between the CO2 emissions (% of total fuel combustion) of Latin America(all income levels) and CO2 emissions (% of total fuel combustion) of Belgium?
Ensure brevity in your answer.  13.92. In the year 1992, what is the difference between the CO2 emissions (% of total fuel combustion) of Latin America(all income levels) and CO2 emissions (% of total fuel combustion) of Cuba?
Offer a very short reply. 20.9. In the year 1992, what is the difference between the CO2 emissions (% of total fuel combustion) in Latin America(all income levels) and CO2 emissions (% of total fuel combustion) in Vietnam?
Ensure brevity in your answer.  9.51. In the year 1992, what is the difference between the CO2 emissions (% of total fuel combustion) of Belgium and CO2 emissions (% of total fuel combustion) of Cuba?
Provide a succinct answer. 6.98. In the year 1992, what is the difference between the CO2 emissions (% of total fuel combustion) of Belgium and CO2 emissions (% of total fuel combustion) of Vietnam?
Your answer should be very brief. -4.41. In the year 1992, what is the difference between the CO2 emissions (% of total fuel combustion) of Cuba and CO2 emissions (% of total fuel combustion) of Vietnam?
Make the answer very short. -11.39. In the year 1993, what is the difference between the CO2 emissions (% of total fuel combustion) of Latin America(all income levels) and CO2 emissions (% of total fuel combustion) of Belgium?
Keep it short and to the point. 13.84. In the year 1993, what is the difference between the CO2 emissions (% of total fuel combustion) of Latin America(all income levels) and CO2 emissions (% of total fuel combustion) of Cuba?
Your response must be concise. 24.02. In the year 1993, what is the difference between the CO2 emissions (% of total fuel combustion) in Latin America(all income levels) and CO2 emissions (% of total fuel combustion) in Vietnam?
Your response must be concise. 1.67. In the year 1993, what is the difference between the CO2 emissions (% of total fuel combustion) in Belgium and CO2 emissions (% of total fuel combustion) in Cuba?
Ensure brevity in your answer.  10.17. In the year 1993, what is the difference between the CO2 emissions (% of total fuel combustion) of Belgium and CO2 emissions (% of total fuel combustion) of Vietnam?
Offer a terse response. -12.17. In the year 1993, what is the difference between the CO2 emissions (% of total fuel combustion) of Cuba and CO2 emissions (% of total fuel combustion) of Vietnam?
Your answer should be very brief. -22.35. What is the ratio of the CO2 emissions (% of total fuel combustion) in Cuba in 1988 to that in 1989?
Give a very brief answer. 1.07. What is the ratio of the CO2 emissions (% of total fuel combustion) in Vietnam in 1988 to that in 1989?
Keep it short and to the point. 0.93. What is the ratio of the CO2 emissions (% of total fuel combustion) in Latin America(all income levels) in 1988 to that in 1990?
Keep it short and to the point. 0.95. What is the ratio of the CO2 emissions (% of total fuel combustion) in Belgium in 1988 to that in 1990?
Ensure brevity in your answer.  1.03. What is the ratio of the CO2 emissions (% of total fuel combustion) of Cuba in 1988 to that in 1990?
Your answer should be very brief. 1.08. What is the ratio of the CO2 emissions (% of total fuel combustion) of Vietnam in 1988 to that in 1990?
Provide a succinct answer. 0.79. What is the ratio of the CO2 emissions (% of total fuel combustion) of Latin America(all income levels) in 1988 to that in 1991?
Ensure brevity in your answer.  0.94. What is the ratio of the CO2 emissions (% of total fuel combustion) of Belgium in 1988 to that in 1991?
Your answer should be compact. 1.05. What is the ratio of the CO2 emissions (% of total fuel combustion) of Cuba in 1988 to that in 1991?
Keep it short and to the point. 1.12. What is the ratio of the CO2 emissions (% of total fuel combustion) of Vietnam in 1988 to that in 1991?
Ensure brevity in your answer.  0.82. What is the ratio of the CO2 emissions (% of total fuel combustion) of Latin America(all income levels) in 1988 to that in 1992?
Offer a terse response. 0.94. What is the ratio of the CO2 emissions (% of total fuel combustion) in Belgium in 1988 to that in 1992?
Make the answer very short. 0.97. What is the ratio of the CO2 emissions (% of total fuel combustion) of Cuba in 1988 to that in 1992?
Offer a very short reply. 1.28. What is the ratio of the CO2 emissions (% of total fuel combustion) of Vietnam in 1988 to that in 1992?
Your answer should be compact. 0.79. What is the ratio of the CO2 emissions (% of total fuel combustion) in Latin America(all income levels) in 1988 to that in 1993?
Your answer should be compact. 0.92. What is the ratio of the CO2 emissions (% of total fuel combustion) in Belgium in 1988 to that in 1993?
Offer a terse response. 0.93. What is the ratio of the CO2 emissions (% of total fuel combustion) of Cuba in 1988 to that in 1993?
Offer a very short reply. 1.57. What is the ratio of the CO2 emissions (% of total fuel combustion) in Vietnam in 1988 to that in 1993?
Keep it short and to the point. 0.58. What is the ratio of the CO2 emissions (% of total fuel combustion) of Latin America(all income levels) in 1989 to that in 1990?
Make the answer very short. 0.95. What is the ratio of the CO2 emissions (% of total fuel combustion) of Belgium in 1989 to that in 1990?
Give a very brief answer. 1.03. What is the ratio of the CO2 emissions (% of total fuel combustion) in Cuba in 1989 to that in 1990?
Provide a succinct answer. 1.01. What is the ratio of the CO2 emissions (% of total fuel combustion) of Vietnam in 1989 to that in 1990?
Offer a terse response. 0.85. What is the ratio of the CO2 emissions (% of total fuel combustion) in Latin America(all income levels) in 1989 to that in 1991?
Give a very brief answer. 0.95. What is the ratio of the CO2 emissions (% of total fuel combustion) of Belgium in 1989 to that in 1991?
Give a very brief answer. 1.06. What is the ratio of the CO2 emissions (% of total fuel combustion) of Cuba in 1989 to that in 1991?
Your answer should be compact. 1.05. What is the ratio of the CO2 emissions (% of total fuel combustion) in Vietnam in 1989 to that in 1991?
Ensure brevity in your answer.  0.88. What is the ratio of the CO2 emissions (% of total fuel combustion) of Latin America(all income levels) in 1989 to that in 1992?
Provide a short and direct response. 0.94. What is the ratio of the CO2 emissions (% of total fuel combustion) of Belgium in 1989 to that in 1992?
Keep it short and to the point. 0.98. What is the ratio of the CO2 emissions (% of total fuel combustion) of Cuba in 1989 to that in 1992?
Provide a succinct answer. 1.2. What is the ratio of the CO2 emissions (% of total fuel combustion) in Vietnam in 1989 to that in 1992?
Ensure brevity in your answer.  0.85. What is the ratio of the CO2 emissions (% of total fuel combustion) in Latin America(all income levels) in 1989 to that in 1993?
Your answer should be compact. 0.92. What is the ratio of the CO2 emissions (% of total fuel combustion) of Belgium in 1989 to that in 1993?
Keep it short and to the point. 0.94. What is the ratio of the CO2 emissions (% of total fuel combustion) in Cuba in 1989 to that in 1993?
Give a very brief answer. 1.48. What is the ratio of the CO2 emissions (% of total fuel combustion) in Vietnam in 1989 to that in 1993?
Keep it short and to the point. 0.62. What is the ratio of the CO2 emissions (% of total fuel combustion) in Belgium in 1990 to that in 1991?
Keep it short and to the point. 1.02. What is the ratio of the CO2 emissions (% of total fuel combustion) of Cuba in 1990 to that in 1991?
Make the answer very short. 1.04. What is the ratio of the CO2 emissions (% of total fuel combustion) of Vietnam in 1990 to that in 1991?
Provide a short and direct response. 1.04. What is the ratio of the CO2 emissions (% of total fuel combustion) in Latin America(all income levels) in 1990 to that in 1992?
Your response must be concise. 0.99. What is the ratio of the CO2 emissions (% of total fuel combustion) of Belgium in 1990 to that in 1992?
Provide a short and direct response. 0.95. What is the ratio of the CO2 emissions (% of total fuel combustion) of Cuba in 1990 to that in 1992?
Ensure brevity in your answer.  1.19. What is the ratio of the CO2 emissions (% of total fuel combustion) in Latin America(all income levels) in 1990 to that in 1993?
Make the answer very short. 0.97. What is the ratio of the CO2 emissions (% of total fuel combustion) in Belgium in 1990 to that in 1993?
Offer a very short reply. 0.91. What is the ratio of the CO2 emissions (% of total fuel combustion) in Cuba in 1990 to that in 1993?
Your answer should be very brief. 1.46. What is the ratio of the CO2 emissions (% of total fuel combustion) of Vietnam in 1990 to that in 1993?
Keep it short and to the point. 0.74. What is the ratio of the CO2 emissions (% of total fuel combustion) of Latin America(all income levels) in 1991 to that in 1992?
Offer a very short reply. 1. What is the ratio of the CO2 emissions (% of total fuel combustion) in Belgium in 1991 to that in 1992?
Your answer should be very brief. 0.93. What is the ratio of the CO2 emissions (% of total fuel combustion) of Cuba in 1991 to that in 1992?
Provide a succinct answer. 1.14. What is the ratio of the CO2 emissions (% of total fuel combustion) in Vietnam in 1991 to that in 1992?
Offer a very short reply. 0.97. What is the ratio of the CO2 emissions (% of total fuel combustion) in Latin America(all income levels) in 1991 to that in 1993?
Your response must be concise. 0.97. What is the ratio of the CO2 emissions (% of total fuel combustion) of Belgium in 1991 to that in 1993?
Provide a short and direct response. 0.89. What is the ratio of the CO2 emissions (% of total fuel combustion) in Cuba in 1991 to that in 1993?
Provide a succinct answer. 1.4. What is the ratio of the CO2 emissions (% of total fuel combustion) of Vietnam in 1991 to that in 1993?
Provide a short and direct response. 0.71. What is the ratio of the CO2 emissions (% of total fuel combustion) of Latin America(all income levels) in 1992 to that in 1993?
Give a very brief answer. 0.98. What is the ratio of the CO2 emissions (% of total fuel combustion) of Belgium in 1992 to that in 1993?
Keep it short and to the point. 0.96. What is the ratio of the CO2 emissions (% of total fuel combustion) of Cuba in 1992 to that in 1993?
Ensure brevity in your answer.  1.23. What is the ratio of the CO2 emissions (% of total fuel combustion) of Vietnam in 1992 to that in 1993?
Give a very brief answer. 0.73. What is the difference between the highest and the second highest CO2 emissions (% of total fuel combustion) of Latin America(all income levels)?
Your answer should be compact. 0.79. What is the difference between the highest and the second highest CO2 emissions (% of total fuel combustion) of Belgium?
Give a very brief answer. 0.87. What is the difference between the highest and the second highest CO2 emissions (% of total fuel combustion) in Cuba?
Offer a very short reply. 1. What is the difference between the highest and the second highest CO2 emissions (% of total fuel combustion) of Vietnam?
Give a very brief answer. 8.59. What is the difference between the highest and the lowest CO2 emissions (% of total fuel combustion) of Latin America(all income levels)?
Keep it short and to the point. 2.76. What is the difference between the highest and the lowest CO2 emissions (% of total fuel combustion) of Belgium?
Make the answer very short. 2.28. What is the difference between the highest and the lowest CO2 emissions (% of total fuel combustion) of Cuba?
Give a very brief answer. 5.85. What is the difference between the highest and the lowest CO2 emissions (% of total fuel combustion) of Vietnam?
Your answer should be very brief. 13.62. 